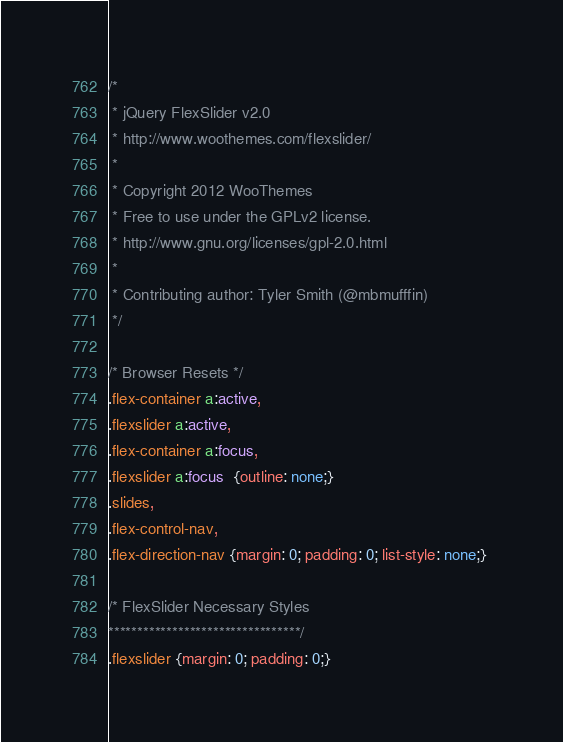<code> <loc_0><loc_0><loc_500><loc_500><_CSS_>/*
 * jQuery FlexSlider v2.0
 * http://www.woothemes.com/flexslider/
 *
 * Copyright 2012 WooThemes
 * Free to use under the GPLv2 license.
 * http://www.gnu.org/licenses/gpl-2.0.html
 *
 * Contributing author: Tyler Smith (@mbmufffin)
 */
 
/* Browser Resets */
.flex-container a:active,
.flexslider a:active,
.flex-container a:focus,
.flexslider a:focus  {outline: none;}
.slides,
.flex-control-nav,
.flex-direction-nav {margin: 0; padding: 0; list-style: none;} 

/* FlexSlider Necessary Styles
*********************************/ 
.flexslider {margin: 0; padding: 0;}</code> 